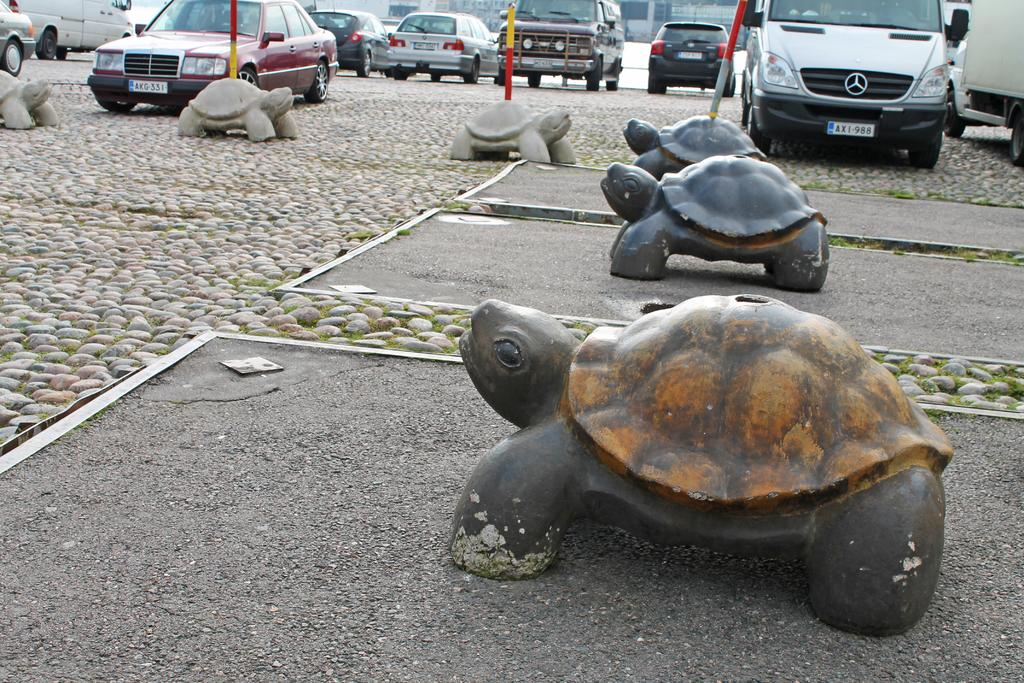What type of animals are on the ground in the image? There are artificial turtles on the ground in the image. What can be seen in the background of the image? There are many cars parked in the background. What else is on the ground besides the turtles? There are stones on the ground. What type of statement can be seen on the turtles in the image? There are no statements visible on the turtles in the image; they are artificial turtles without any text or labels. 